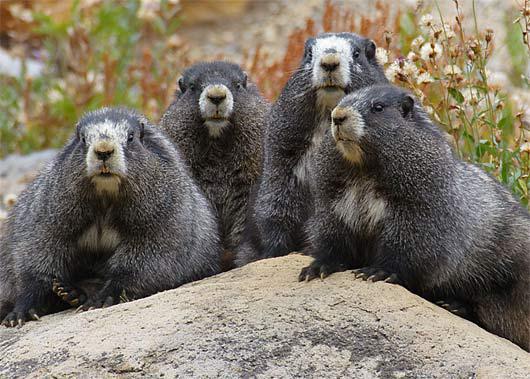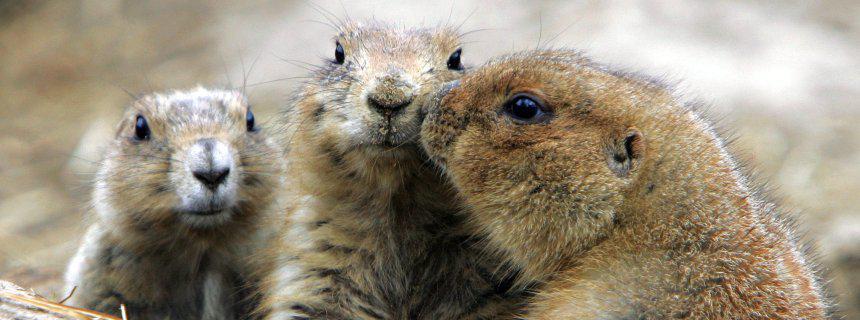The first image is the image on the left, the second image is the image on the right. For the images shown, is this caption "An image shows three upright marmots facing the same general direction and clutching food." true? Answer yes or no. No. 